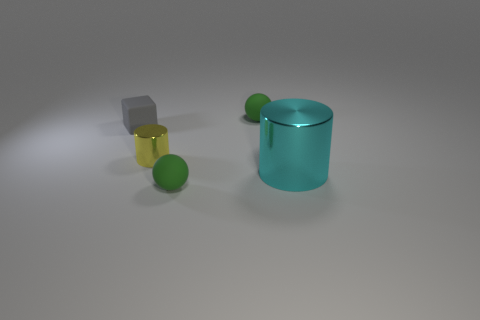Are there any other things that are the same size as the cyan thing?
Provide a succinct answer. No. Are there any tiny cylinders that have the same material as the big cylinder?
Provide a short and direct response. Yes. What is the material of the cube that is the same size as the yellow shiny thing?
Your response must be concise. Rubber. What color is the object that is in front of the rubber cube and behind the large metal object?
Offer a very short reply. Yellow. Is the number of tiny gray rubber objects to the right of the cyan metal thing less than the number of objects that are left of the tiny yellow object?
Keep it short and to the point. Yes. What number of tiny yellow shiny things have the same shape as the cyan shiny object?
Provide a succinct answer. 1. The other yellow cylinder that is made of the same material as the large cylinder is what size?
Make the answer very short. Small. There is a small sphere in front of the cylinder on the left side of the big metallic thing; what is its color?
Provide a succinct answer. Green. Does the yellow metallic object have the same shape as the big metallic object that is in front of the small shiny thing?
Your answer should be very brief. Yes. What number of gray things are the same size as the yellow shiny object?
Offer a terse response. 1. 